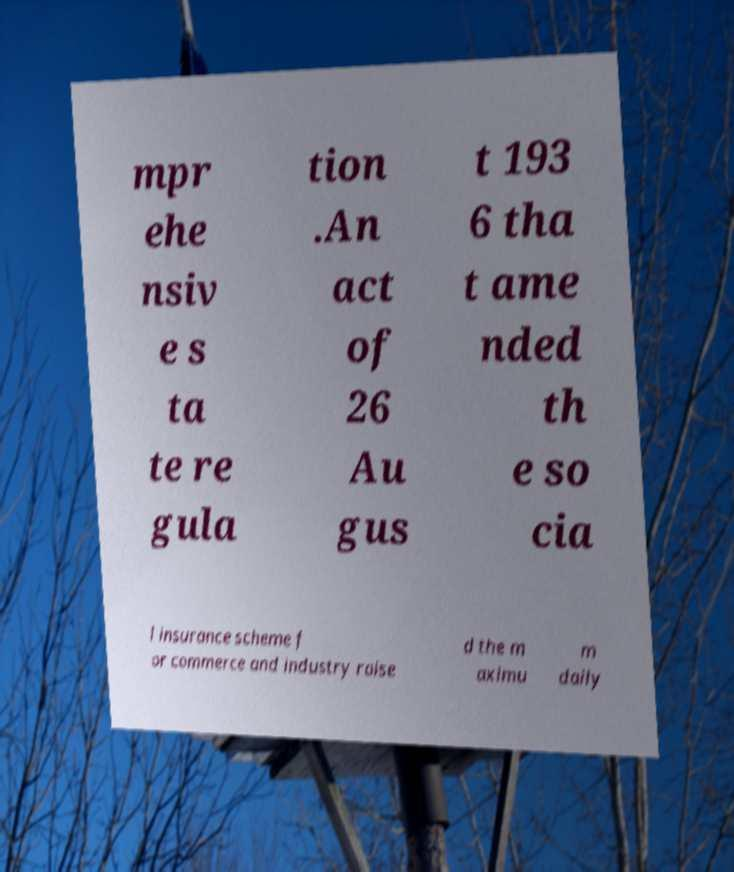Can you read and provide the text displayed in the image?This photo seems to have some interesting text. Can you extract and type it out for me? mpr ehe nsiv e s ta te re gula tion .An act of 26 Au gus t 193 6 tha t ame nded th e so cia l insurance scheme f or commerce and industry raise d the m aximu m daily 